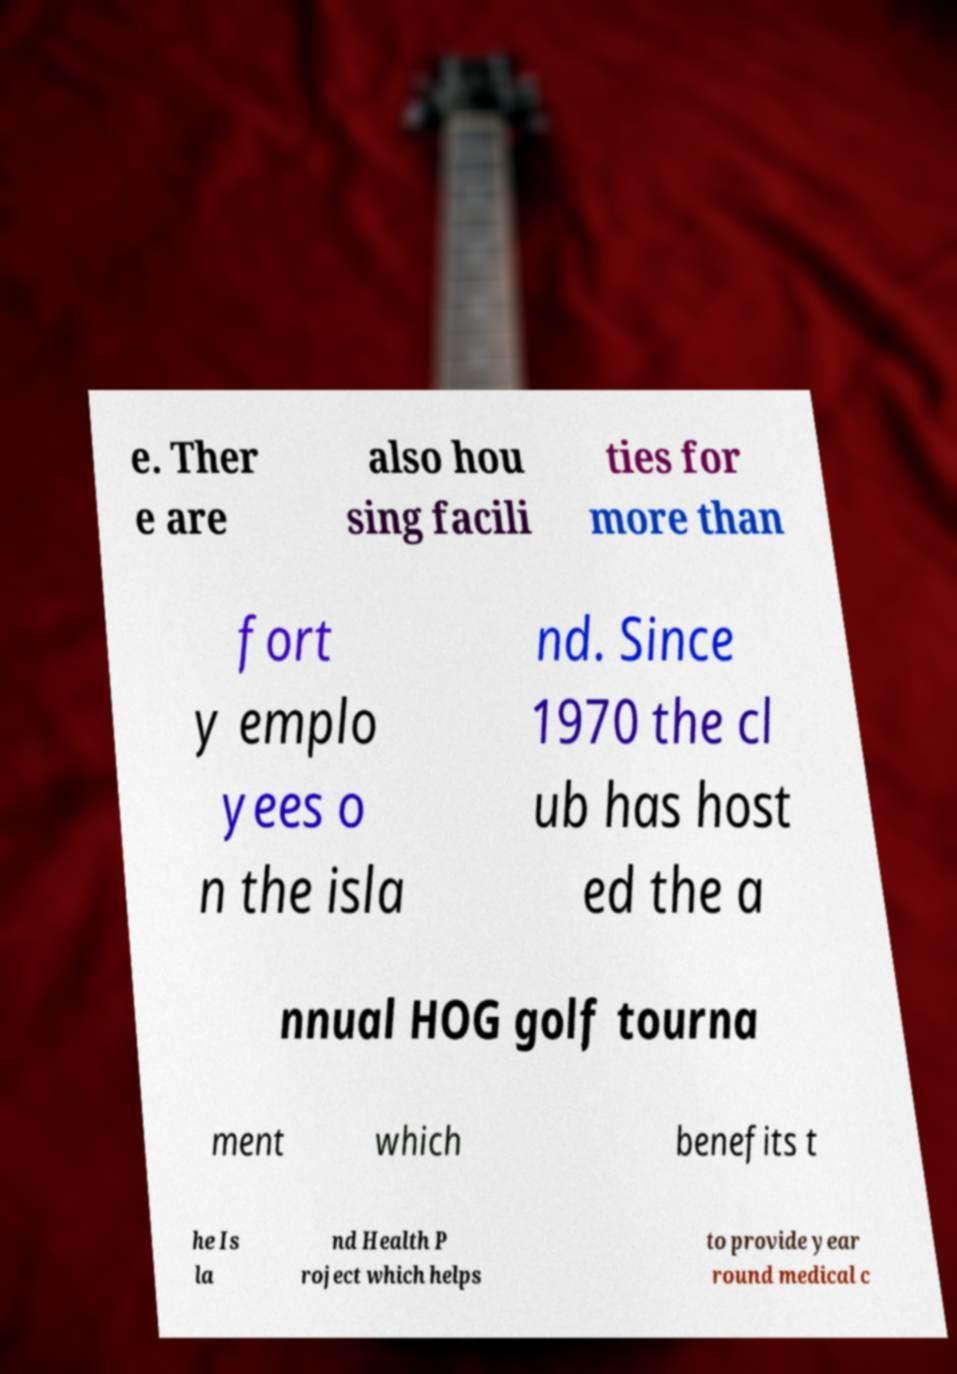Can you read and provide the text displayed in the image?This photo seems to have some interesting text. Can you extract and type it out for me? e. Ther e are also hou sing facili ties for more than fort y emplo yees o n the isla nd. Since 1970 the cl ub has host ed the a nnual HOG golf tourna ment which benefits t he Is la nd Health P roject which helps to provide year round medical c 